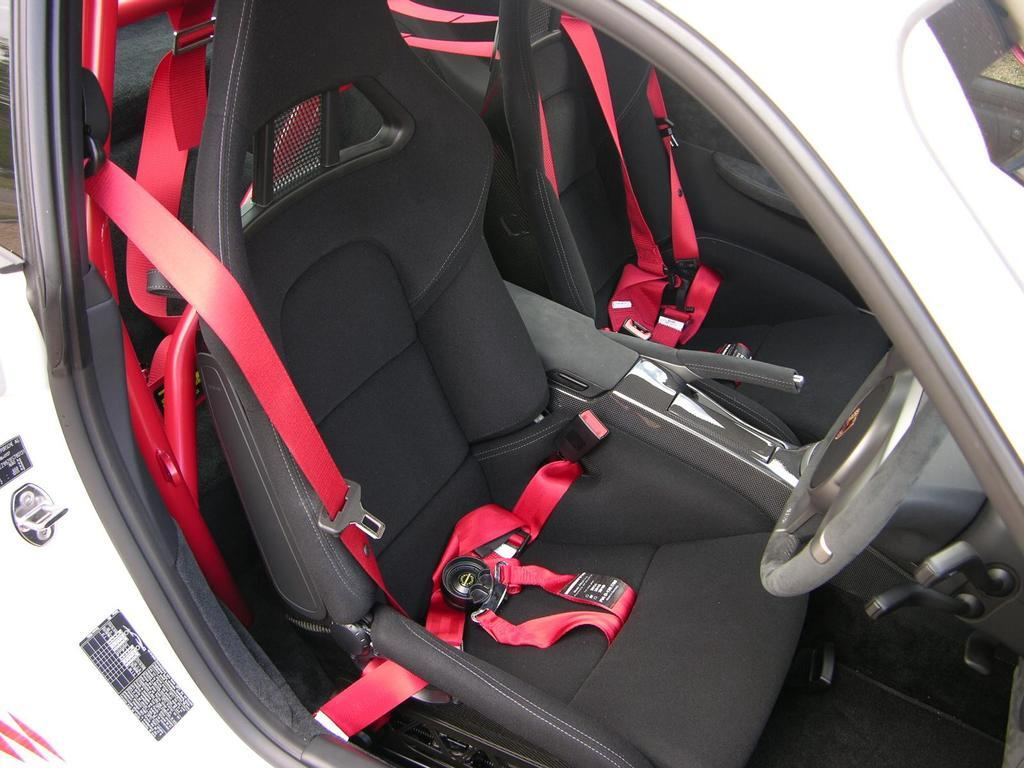What is the setting of the image? The image shows the inside of a car. What safety feature can be seen in the car? There are red seat belts visible in the car. Who is the creator of the table in the image? There is no table present in the image; it shows the inside of a car. 